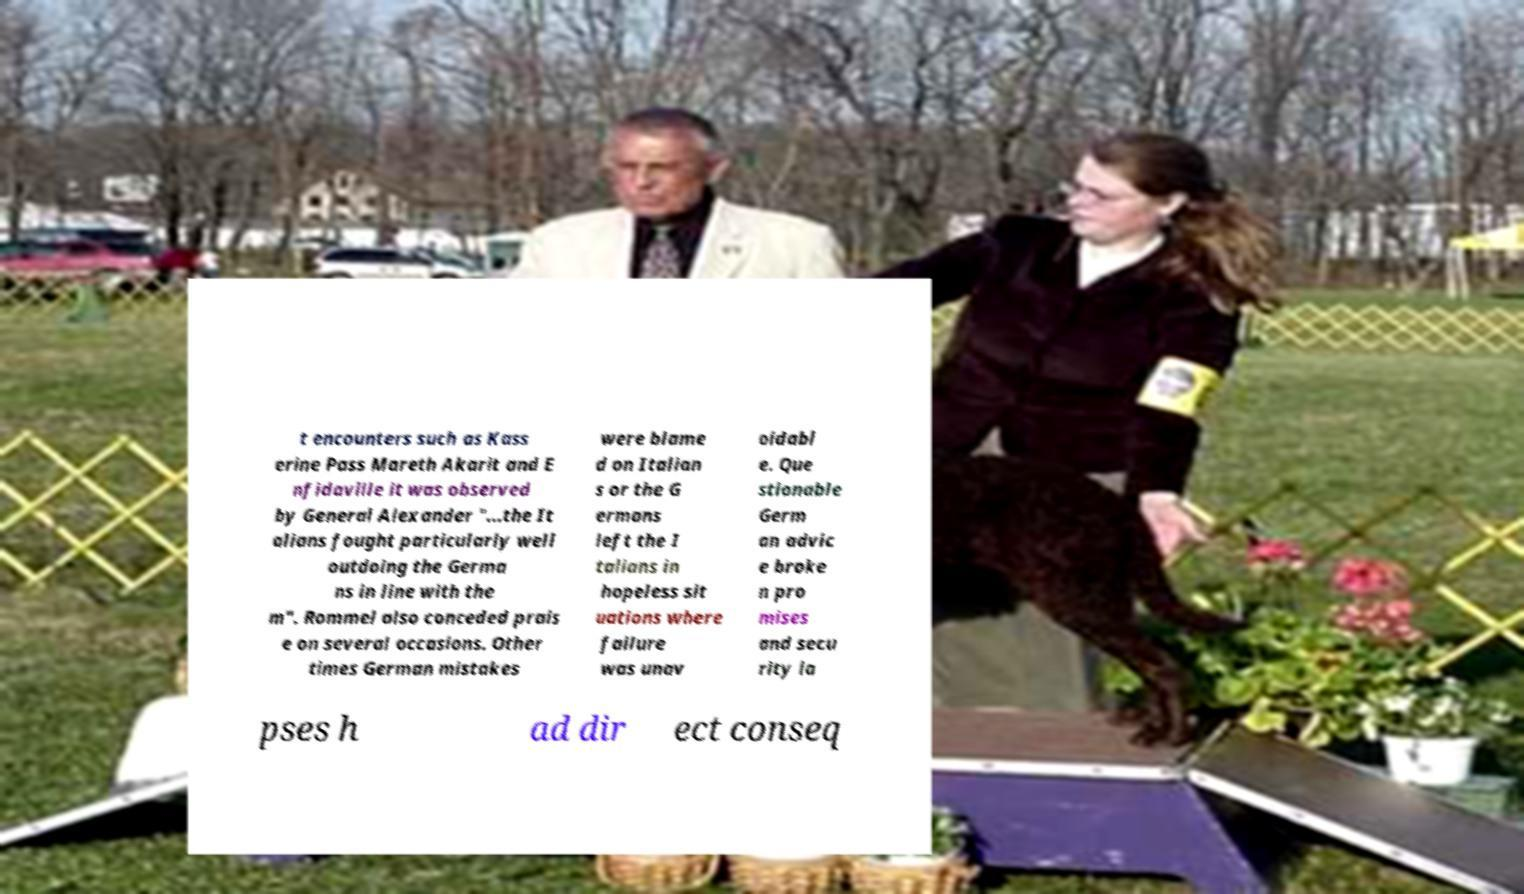Can you accurately transcribe the text from the provided image for me? t encounters such as Kass erine Pass Mareth Akarit and E nfidaville it was observed by General Alexander "...the It alians fought particularly well outdoing the Germa ns in line with the m". Rommel also conceded prais e on several occasions. Other times German mistakes were blame d on Italian s or the G ermans left the I talians in hopeless sit uations where failure was unav oidabl e. Que stionable Germ an advic e broke n pro mises and secu rity la pses h ad dir ect conseq 